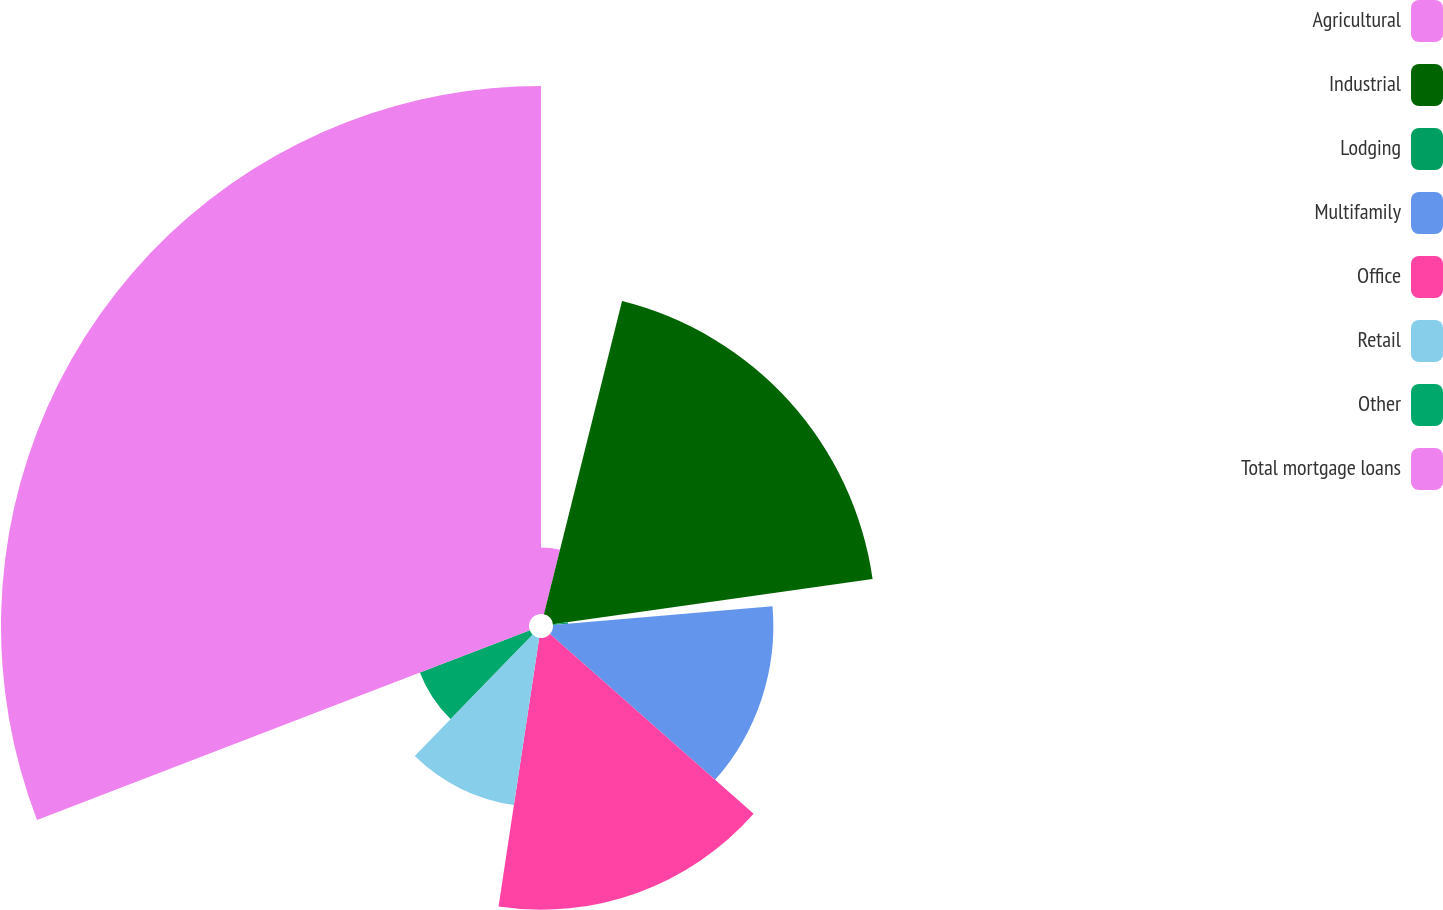Convert chart to OTSL. <chart><loc_0><loc_0><loc_500><loc_500><pie_chart><fcel>Agricultural<fcel>Industrial<fcel>Lodging<fcel>Multifamily<fcel>Office<fcel>Retail<fcel>Other<fcel>Total mortgage loans<nl><fcel>3.89%<fcel>18.86%<fcel>0.89%<fcel>12.87%<fcel>15.87%<fcel>9.88%<fcel>6.88%<fcel>30.84%<nl></chart> 